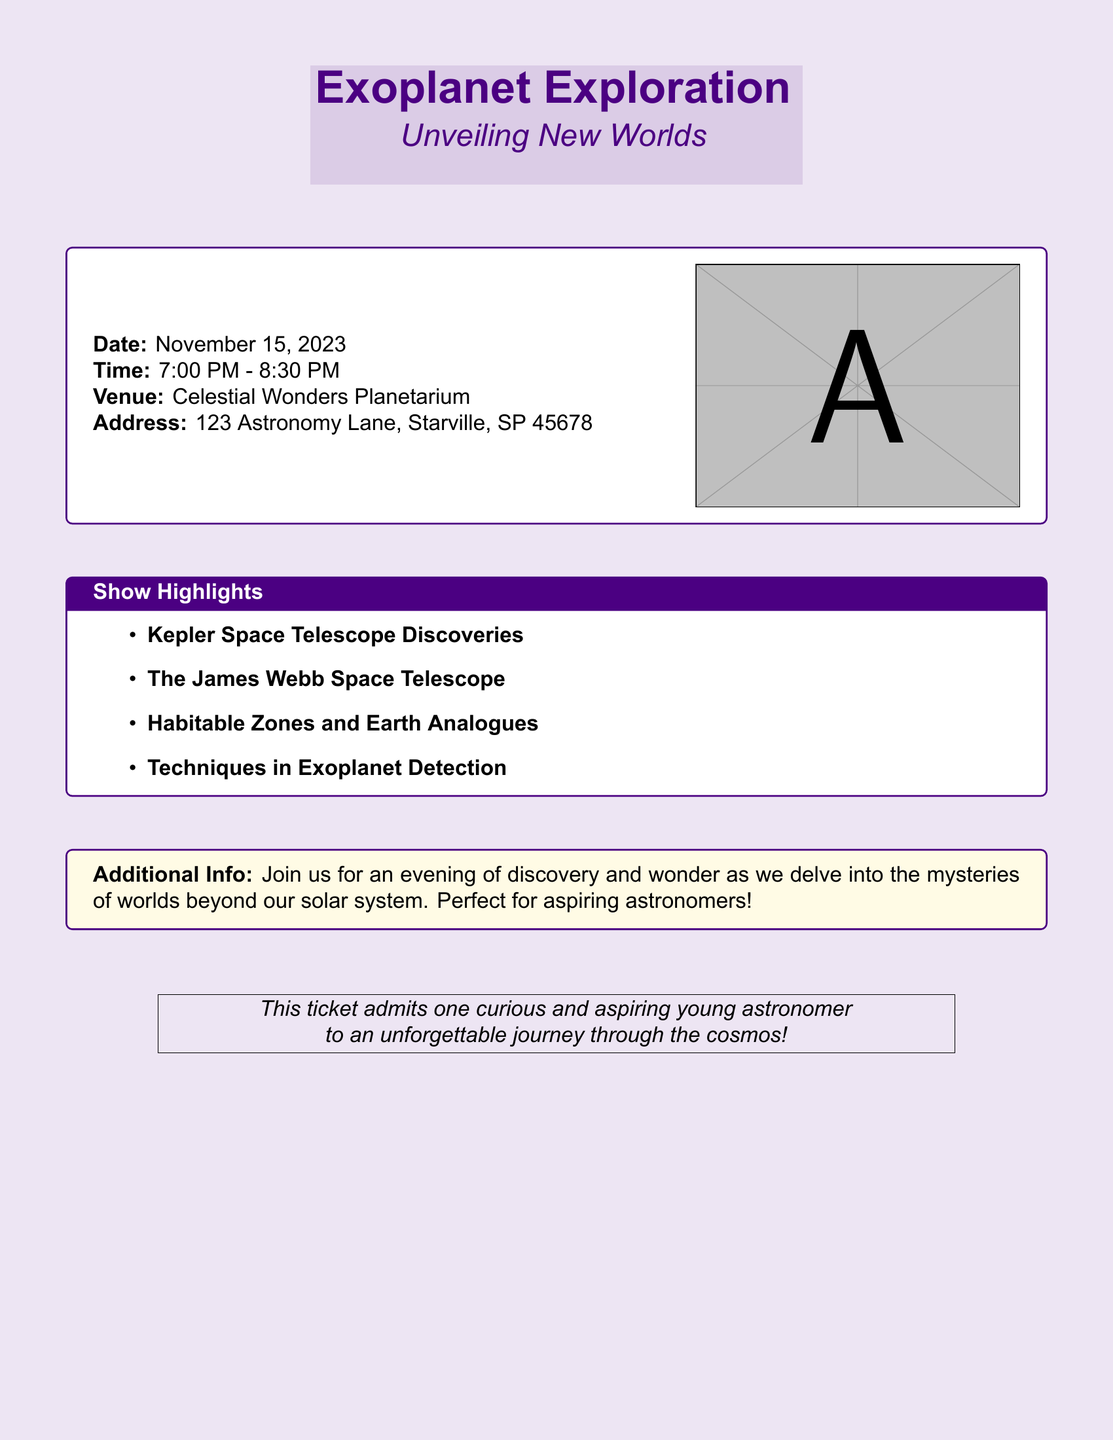What is the date of the show? The date of the show is explicitly mentioned in the document.
Answer: November 15, 2023 What time does the show start? The start time is provided in the schedule section of the document.
Answer: 7:00 PM Where is the show located? The location is specified in the venue section of the document.
Answer: Celestial Wonders Planetarium What is one of the highlights discussed in the show? The document lists several highlights of the show.
Answer: Kepler Space Telescope Discoveries How long is the show? The duration of the show is calculated based on the start and end times given in the document.
Answer: 1 hour 30 minutes What is the address of the venue? The complete address is included in the venue section of the document.
Answer: 123 Astronomy Lane, Starville, SP 45678 What type of audience is the show perfect for? The document mentions the target audience for the event.
Answer: Aspiring astronomers What is the title of the show? The title is clearly highlighted at the beginning of the document.
Answer: Exoplanet Exploration What telescope is mentioned as a highlight of the discoveries? The document refers to a specific telescope in the show highlights.
Answer: The James Webb Space Telescope 